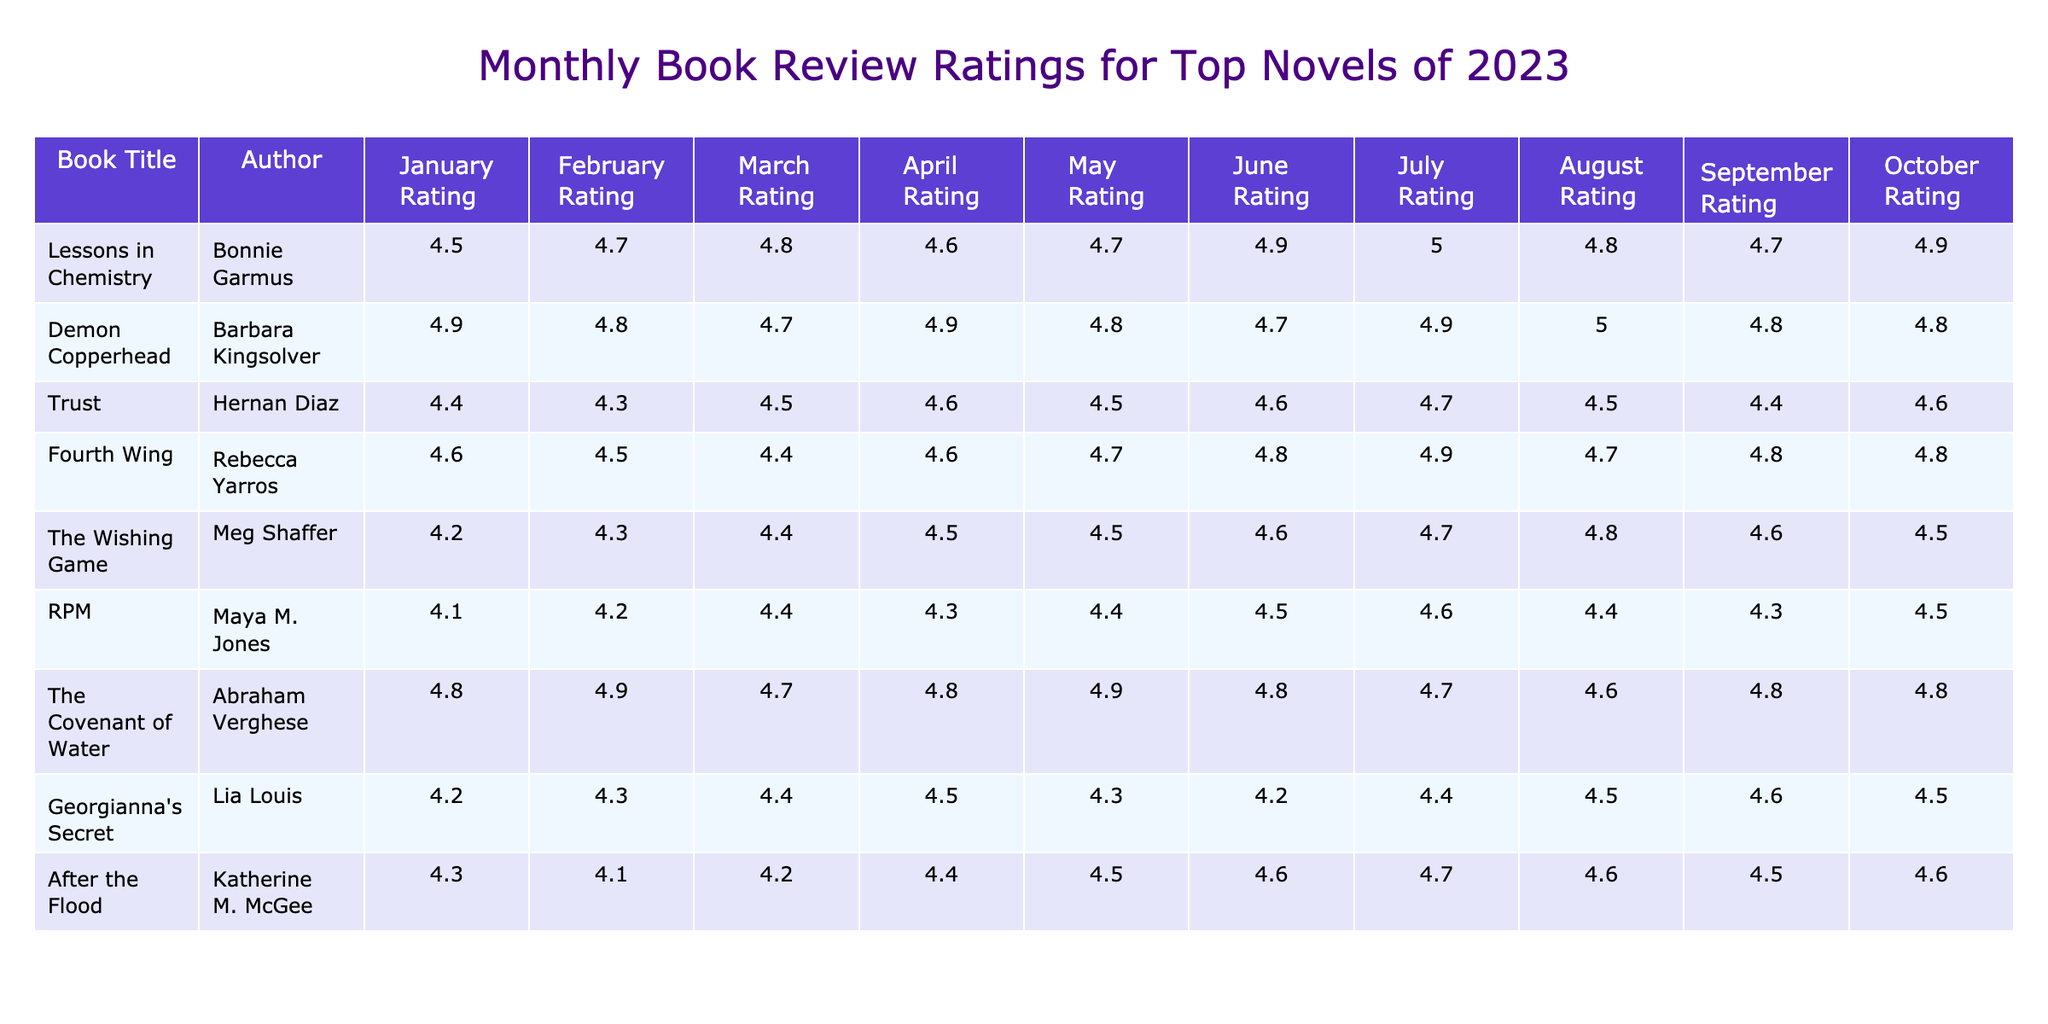What is the highest rating achieved by "Lessons in Chemistry"? Looking at the ratings for "Lessons in Chemistry", the highest rating across all months is 5.0 in July.
Answer: 5.0 Which book has the lowest average rating across all months? By calculating the average for each book, "RPM" has the lowest ratings: (4.1 + 4.2 + 4.4 + 4.3 + 4.4 + 4.5 + 4.6 + 4.4 + 4.3 + 4.5) / 10 = 4.41.
Answer: RPM Did "Demon Copperhead" maintain a rating above 4.5 throughout the year? By checking each month's ratings for "Demon Copperhead", it shows ratings of 4.9, 4.8, 4.7, 4.9, 4.8, 4.7, 4.9, 5.0, 4.8, and 4.8, which are all above 4.5.
Answer: Yes What was the average rating for "Trust" over the first half of the year? To find the average for "Trust" from January to June, sum the ratings: (4.4 + 4.3 + 4.5 + 4.6 + 4.5 + 4.6) = 26.9, then divide by 6 which equals approximately 4.48.
Answer: 4.48 Which author had the book with the biggest rating increase from January to October? Observing the ratings, "Lessons in Chemistry" increased from 4.5 in January to 4.9 in October, a difference of 0.4, while "The Covenant of Water" had a smaller increase of 0.0 (4.8 to 4.8).
Answer: Bonnie Garmus Is there a month where "Fourth Wing" received a rating lower than 4.5? Checking each monthly rating, "Fourth Wing" shows ratings of 4.6, 4.5, 4.4, 4.6, 4.7, 4.8, 4.9, 4.7, 4.8, and 4.8; it indeed dropped below 4.5 in March (4.4).
Answer: Yes Which book consistently improved in ratings month-over-month? By examining the ratings month-to-month, "Lessons in Chemistry" consistently improved from 4.5 in January to 5.0 in July and maintained high ratings thereafter.
Answer: Lessons in Chemistry How many books had an average rating of 4.7 or higher throughout the year? Calculate the averages for each book and determine which ones meet the criteria: "Lessons in Chemistry", "Demon Copperhead", "The Covenant of Water", and "Fourth Wing" all exceeded 4.7. Thus, that makes 4 books.
Answer: 4 